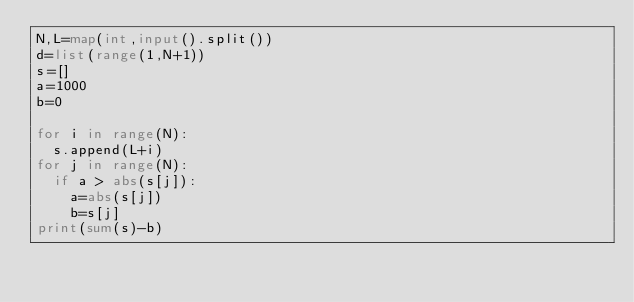<code> <loc_0><loc_0><loc_500><loc_500><_Python_>N,L=map(int,input().split())
d=list(range(1,N+1))
s=[]
a=1000
b=0

for i in range(N):
  s.append(L+i)
for j in range(N):
  if a > abs(s[j]):
    a=abs(s[j])
    b=s[j]
print(sum(s)-b)</code> 